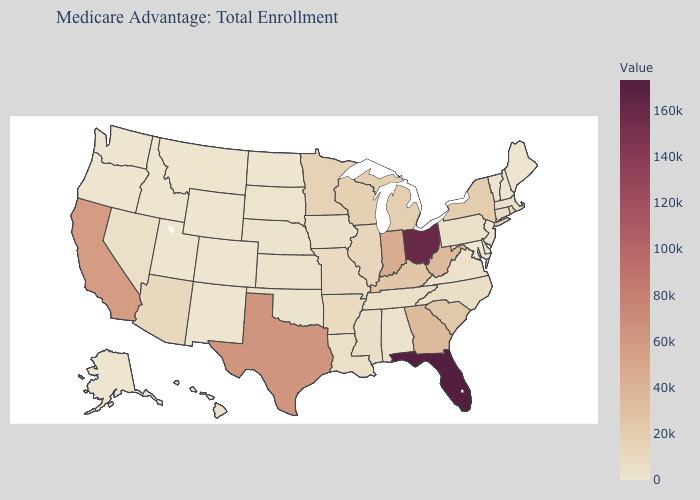Is the legend a continuous bar?
Be succinct. Yes. Which states hav the highest value in the West?
Concise answer only. California. Does Utah have a higher value than South Carolina?
Answer briefly. No. Does Montana have a higher value than Indiana?
Quick response, please. No. 